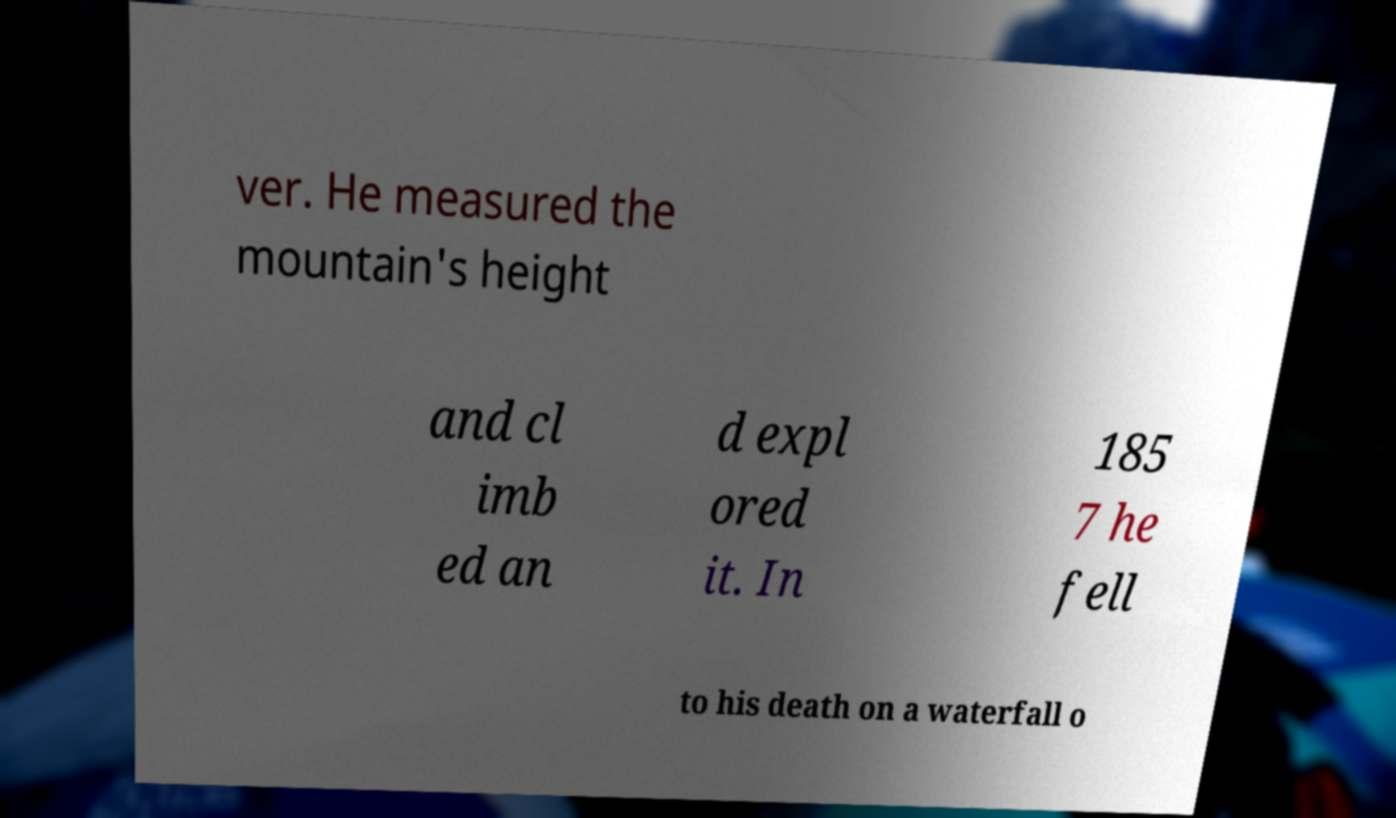Can you accurately transcribe the text from the provided image for me? ver. He measured the mountain's height and cl imb ed an d expl ored it. In 185 7 he fell to his death on a waterfall o 